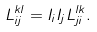Convert formula to latex. <formula><loc_0><loc_0><loc_500><loc_500>L _ { i j } ^ { k l } = I _ { i } I _ { j } L _ { j i } ^ { l k } .</formula> 